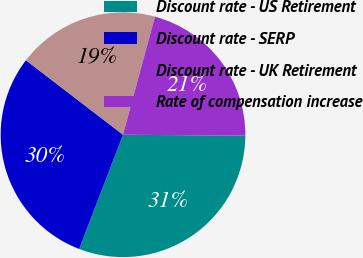Convert chart to OTSL. <chart><loc_0><loc_0><loc_500><loc_500><pie_chart><fcel>Discount rate - US Retirement<fcel>Discount rate - SERP<fcel>Discount rate - UK Retirement<fcel>Rate of compensation increase<nl><fcel>30.72%<fcel>29.58%<fcel>18.79%<fcel>20.92%<nl></chart> 